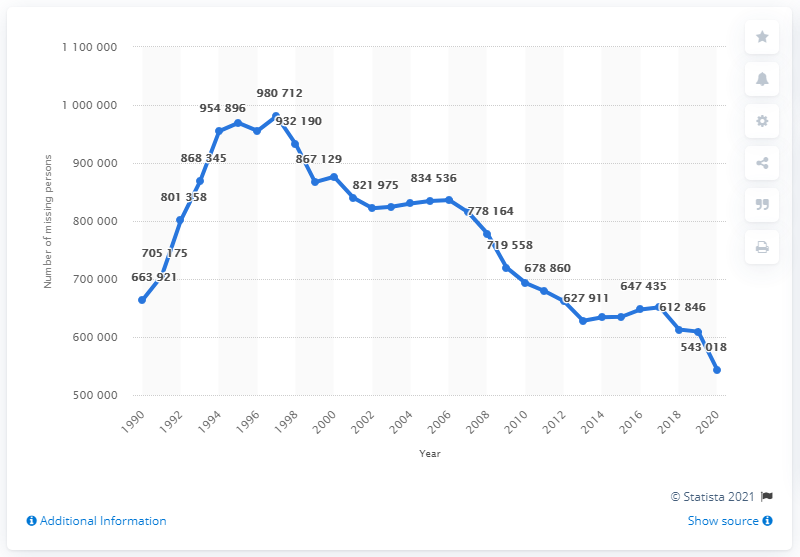Mention a couple of crucial points in this snapshot. There were the fewest number of missing person files in the United States in 1990. 